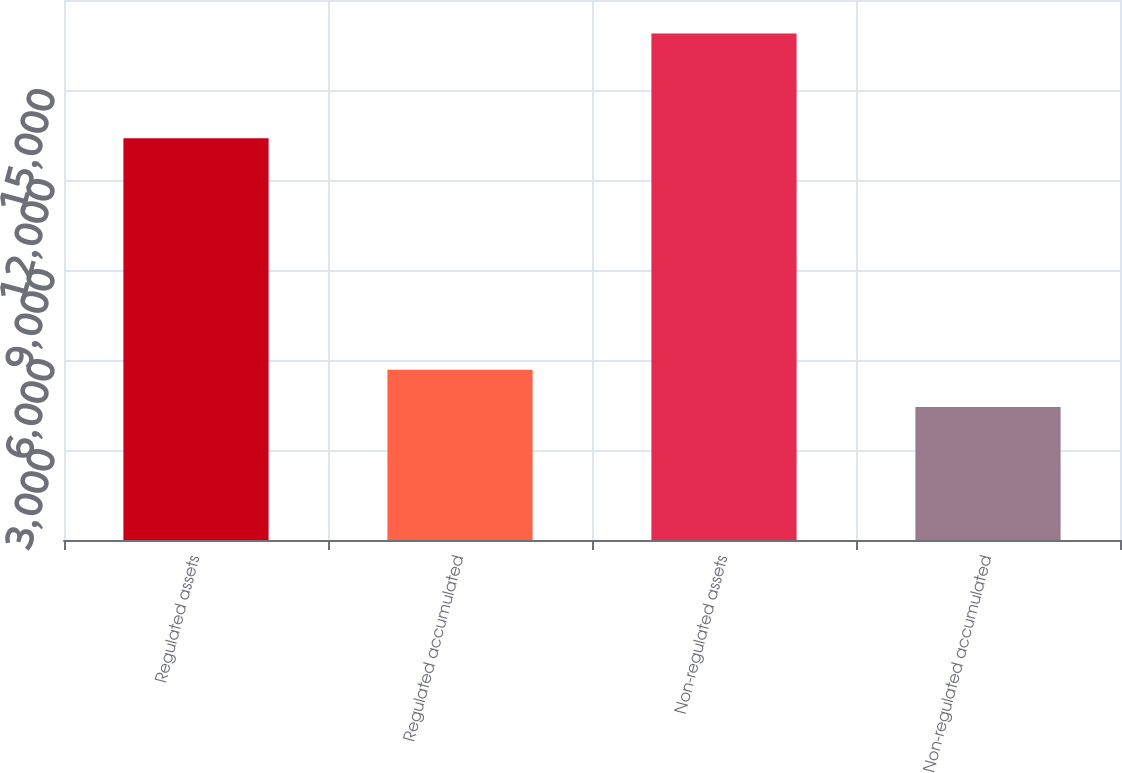Convert chart. <chart><loc_0><loc_0><loc_500><loc_500><bar_chart><fcel>Regulated assets<fcel>Regulated accumulated<fcel>Non-regulated assets<fcel>Non-regulated accumulated<nl><fcel>13395<fcel>5678.9<fcel>16883<fcel>4434<nl></chart> 